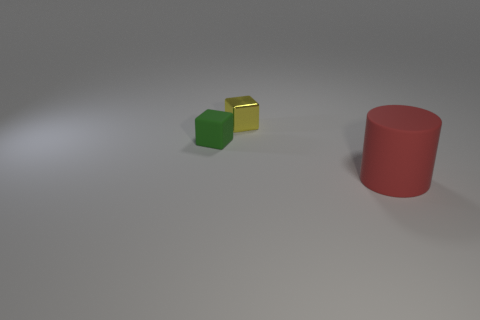Add 3 small red metallic cylinders. How many objects exist? 6 Subtract all blocks. How many objects are left? 1 Add 1 big red rubber things. How many big red rubber things are left? 2 Add 2 large red rubber things. How many large red rubber things exist? 3 Subtract 1 green cubes. How many objects are left? 2 Subtract all brown cylinders. Subtract all yellow cubes. How many cylinders are left? 1 Subtract all tiny cyan metal balls. Subtract all yellow metal objects. How many objects are left? 2 